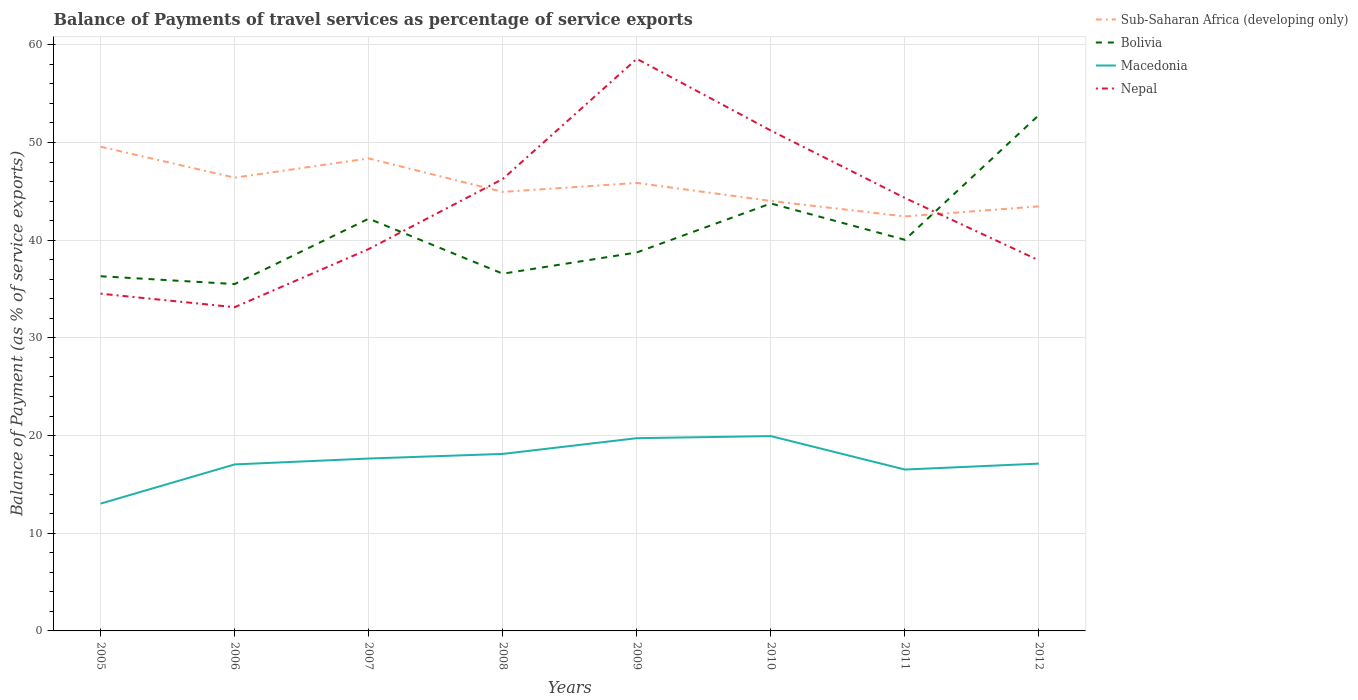How many different coloured lines are there?
Ensure brevity in your answer.  4. Does the line corresponding to Macedonia intersect with the line corresponding to Nepal?
Offer a very short reply. No. Across all years, what is the maximum balance of payments of travel services in Nepal?
Ensure brevity in your answer.  33.14. In which year was the balance of payments of travel services in Sub-Saharan Africa (developing only) maximum?
Keep it short and to the point. 2011. What is the total balance of payments of travel services in Macedonia in the graph?
Make the answer very short. 0.99. What is the difference between the highest and the second highest balance of payments of travel services in Sub-Saharan Africa (developing only)?
Your answer should be compact. 7.14. Is the balance of payments of travel services in Nepal strictly greater than the balance of payments of travel services in Macedonia over the years?
Offer a terse response. No. What is the difference between two consecutive major ticks on the Y-axis?
Make the answer very short. 10. Are the values on the major ticks of Y-axis written in scientific E-notation?
Offer a terse response. No. Does the graph contain any zero values?
Provide a succinct answer. No. How are the legend labels stacked?
Offer a very short reply. Vertical. What is the title of the graph?
Your answer should be compact. Balance of Payments of travel services as percentage of service exports. Does "West Bank and Gaza" appear as one of the legend labels in the graph?
Provide a succinct answer. No. What is the label or title of the Y-axis?
Offer a terse response. Balance of Payment (as % of service exports). What is the Balance of Payment (as % of service exports) in Sub-Saharan Africa (developing only) in 2005?
Ensure brevity in your answer.  49.57. What is the Balance of Payment (as % of service exports) in Bolivia in 2005?
Your answer should be very brief. 36.31. What is the Balance of Payment (as % of service exports) of Macedonia in 2005?
Provide a succinct answer. 13.03. What is the Balance of Payment (as % of service exports) of Nepal in 2005?
Ensure brevity in your answer.  34.52. What is the Balance of Payment (as % of service exports) of Sub-Saharan Africa (developing only) in 2006?
Offer a very short reply. 46.4. What is the Balance of Payment (as % of service exports) of Bolivia in 2006?
Offer a very short reply. 35.51. What is the Balance of Payment (as % of service exports) in Macedonia in 2006?
Ensure brevity in your answer.  17.05. What is the Balance of Payment (as % of service exports) of Nepal in 2006?
Make the answer very short. 33.14. What is the Balance of Payment (as % of service exports) in Sub-Saharan Africa (developing only) in 2007?
Offer a terse response. 48.37. What is the Balance of Payment (as % of service exports) in Bolivia in 2007?
Offer a terse response. 42.2. What is the Balance of Payment (as % of service exports) in Macedonia in 2007?
Give a very brief answer. 17.65. What is the Balance of Payment (as % of service exports) of Nepal in 2007?
Make the answer very short. 39.09. What is the Balance of Payment (as % of service exports) in Sub-Saharan Africa (developing only) in 2008?
Offer a terse response. 44.94. What is the Balance of Payment (as % of service exports) in Bolivia in 2008?
Make the answer very short. 36.57. What is the Balance of Payment (as % of service exports) of Macedonia in 2008?
Ensure brevity in your answer.  18.12. What is the Balance of Payment (as % of service exports) of Nepal in 2008?
Make the answer very short. 46.26. What is the Balance of Payment (as % of service exports) in Sub-Saharan Africa (developing only) in 2009?
Offer a very short reply. 45.86. What is the Balance of Payment (as % of service exports) of Bolivia in 2009?
Provide a short and direct response. 38.75. What is the Balance of Payment (as % of service exports) in Macedonia in 2009?
Your response must be concise. 19.73. What is the Balance of Payment (as % of service exports) in Nepal in 2009?
Provide a succinct answer. 58.57. What is the Balance of Payment (as % of service exports) in Sub-Saharan Africa (developing only) in 2010?
Make the answer very short. 44.02. What is the Balance of Payment (as % of service exports) of Bolivia in 2010?
Offer a terse response. 43.76. What is the Balance of Payment (as % of service exports) of Macedonia in 2010?
Ensure brevity in your answer.  19.94. What is the Balance of Payment (as % of service exports) of Nepal in 2010?
Give a very brief answer. 51.23. What is the Balance of Payment (as % of service exports) of Sub-Saharan Africa (developing only) in 2011?
Ensure brevity in your answer.  42.43. What is the Balance of Payment (as % of service exports) in Bolivia in 2011?
Ensure brevity in your answer.  40.04. What is the Balance of Payment (as % of service exports) of Macedonia in 2011?
Your response must be concise. 16.52. What is the Balance of Payment (as % of service exports) of Nepal in 2011?
Your answer should be compact. 44.33. What is the Balance of Payment (as % of service exports) of Sub-Saharan Africa (developing only) in 2012?
Make the answer very short. 43.46. What is the Balance of Payment (as % of service exports) of Bolivia in 2012?
Your answer should be very brief. 52.82. What is the Balance of Payment (as % of service exports) in Macedonia in 2012?
Your answer should be compact. 17.13. What is the Balance of Payment (as % of service exports) of Nepal in 2012?
Offer a very short reply. 37.93. Across all years, what is the maximum Balance of Payment (as % of service exports) of Sub-Saharan Africa (developing only)?
Your answer should be compact. 49.57. Across all years, what is the maximum Balance of Payment (as % of service exports) of Bolivia?
Make the answer very short. 52.82. Across all years, what is the maximum Balance of Payment (as % of service exports) in Macedonia?
Give a very brief answer. 19.94. Across all years, what is the maximum Balance of Payment (as % of service exports) of Nepal?
Offer a terse response. 58.57. Across all years, what is the minimum Balance of Payment (as % of service exports) in Sub-Saharan Africa (developing only)?
Provide a succinct answer. 42.43. Across all years, what is the minimum Balance of Payment (as % of service exports) of Bolivia?
Your answer should be very brief. 35.51. Across all years, what is the minimum Balance of Payment (as % of service exports) in Macedonia?
Offer a terse response. 13.03. Across all years, what is the minimum Balance of Payment (as % of service exports) in Nepal?
Give a very brief answer. 33.14. What is the total Balance of Payment (as % of service exports) in Sub-Saharan Africa (developing only) in the graph?
Your answer should be very brief. 365.07. What is the total Balance of Payment (as % of service exports) of Bolivia in the graph?
Provide a short and direct response. 325.96. What is the total Balance of Payment (as % of service exports) in Macedonia in the graph?
Give a very brief answer. 139.17. What is the total Balance of Payment (as % of service exports) in Nepal in the graph?
Provide a succinct answer. 345.08. What is the difference between the Balance of Payment (as % of service exports) in Sub-Saharan Africa (developing only) in 2005 and that in 2006?
Your answer should be very brief. 3.17. What is the difference between the Balance of Payment (as % of service exports) in Bolivia in 2005 and that in 2006?
Provide a succinct answer. 0.8. What is the difference between the Balance of Payment (as % of service exports) in Macedonia in 2005 and that in 2006?
Keep it short and to the point. -4.01. What is the difference between the Balance of Payment (as % of service exports) in Nepal in 2005 and that in 2006?
Keep it short and to the point. 1.38. What is the difference between the Balance of Payment (as % of service exports) in Sub-Saharan Africa (developing only) in 2005 and that in 2007?
Offer a very short reply. 1.2. What is the difference between the Balance of Payment (as % of service exports) of Bolivia in 2005 and that in 2007?
Offer a terse response. -5.89. What is the difference between the Balance of Payment (as % of service exports) in Macedonia in 2005 and that in 2007?
Your answer should be very brief. -4.61. What is the difference between the Balance of Payment (as % of service exports) in Nepal in 2005 and that in 2007?
Make the answer very short. -4.57. What is the difference between the Balance of Payment (as % of service exports) of Sub-Saharan Africa (developing only) in 2005 and that in 2008?
Keep it short and to the point. 4.63. What is the difference between the Balance of Payment (as % of service exports) of Bolivia in 2005 and that in 2008?
Give a very brief answer. -0.26. What is the difference between the Balance of Payment (as % of service exports) of Macedonia in 2005 and that in 2008?
Offer a terse response. -5.09. What is the difference between the Balance of Payment (as % of service exports) in Nepal in 2005 and that in 2008?
Offer a terse response. -11.74. What is the difference between the Balance of Payment (as % of service exports) in Sub-Saharan Africa (developing only) in 2005 and that in 2009?
Provide a short and direct response. 3.71. What is the difference between the Balance of Payment (as % of service exports) of Bolivia in 2005 and that in 2009?
Make the answer very short. -2.44. What is the difference between the Balance of Payment (as % of service exports) in Macedonia in 2005 and that in 2009?
Provide a short and direct response. -6.7. What is the difference between the Balance of Payment (as % of service exports) of Nepal in 2005 and that in 2009?
Your answer should be compact. -24.05. What is the difference between the Balance of Payment (as % of service exports) in Sub-Saharan Africa (developing only) in 2005 and that in 2010?
Offer a very short reply. 5.55. What is the difference between the Balance of Payment (as % of service exports) in Bolivia in 2005 and that in 2010?
Keep it short and to the point. -7.45. What is the difference between the Balance of Payment (as % of service exports) in Macedonia in 2005 and that in 2010?
Your answer should be compact. -6.91. What is the difference between the Balance of Payment (as % of service exports) in Nepal in 2005 and that in 2010?
Keep it short and to the point. -16.7. What is the difference between the Balance of Payment (as % of service exports) of Sub-Saharan Africa (developing only) in 2005 and that in 2011?
Provide a succinct answer. 7.14. What is the difference between the Balance of Payment (as % of service exports) of Bolivia in 2005 and that in 2011?
Make the answer very short. -3.73. What is the difference between the Balance of Payment (as % of service exports) in Macedonia in 2005 and that in 2011?
Ensure brevity in your answer.  -3.49. What is the difference between the Balance of Payment (as % of service exports) of Nepal in 2005 and that in 2011?
Your answer should be very brief. -9.8. What is the difference between the Balance of Payment (as % of service exports) in Sub-Saharan Africa (developing only) in 2005 and that in 2012?
Offer a terse response. 6.11. What is the difference between the Balance of Payment (as % of service exports) in Bolivia in 2005 and that in 2012?
Your answer should be compact. -16.51. What is the difference between the Balance of Payment (as % of service exports) of Macedonia in 2005 and that in 2012?
Keep it short and to the point. -4.09. What is the difference between the Balance of Payment (as % of service exports) of Nepal in 2005 and that in 2012?
Ensure brevity in your answer.  -3.41. What is the difference between the Balance of Payment (as % of service exports) of Sub-Saharan Africa (developing only) in 2006 and that in 2007?
Provide a short and direct response. -1.97. What is the difference between the Balance of Payment (as % of service exports) in Bolivia in 2006 and that in 2007?
Make the answer very short. -6.69. What is the difference between the Balance of Payment (as % of service exports) of Macedonia in 2006 and that in 2007?
Give a very brief answer. -0.6. What is the difference between the Balance of Payment (as % of service exports) of Nepal in 2006 and that in 2007?
Ensure brevity in your answer.  -5.95. What is the difference between the Balance of Payment (as % of service exports) in Sub-Saharan Africa (developing only) in 2006 and that in 2008?
Keep it short and to the point. 1.46. What is the difference between the Balance of Payment (as % of service exports) of Bolivia in 2006 and that in 2008?
Provide a short and direct response. -1.06. What is the difference between the Balance of Payment (as % of service exports) in Macedonia in 2006 and that in 2008?
Keep it short and to the point. -1.08. What is the difference between the Balance of Payment (as % of service exports) of Nepal in 2006 and that in 2008?
Provide a short and direct response. -13.12. What is the difference between the Balance of Payment (as % of service exports) of Sub-Saharan Africa (developing only) in 2006 and that in 2009?
Provide a short and direct response. 0.54. What is the difference between the Balance of Payment (as % of service exports) of Bolivia in 2006 and that in 2009?
Offer a very short reply. -3.24. What is the difference between the Balance of Payment (as % of service exports) in Macedonia in 2006 and that in 2009?
Your answer should be very brief. -2.69. What is the difference between the Balance of Payment (as % of service exports) of Nepal in 2006 and that in 2009?
Keep it short and to the point. -25.43. What is the difference between the Balance of Payment (as % of service exports) in Sub-Saharan Africa (developing only) in 2006 and that in 2010?
Provide a succinct answer. 2.38. What is the difference between the Balance of Payment (as % of service exports) in Bolivia in 2006 and that in 2010?
Provide a short and direct response. -8.25. What is the difference between the Balance of Payment (as % of service exports) in Macedonia in 2006 and that in 2010?
Your response must be concise. -2.9. What is the difference between the Balance of Payment (as % of service exports) in Nepal in 2006 and that in 2010?
Keep it short and to the point. -18.08. What is the difference between the Balance of Payment (as % of service exports) in Sub-Saharan Africa (developing only) in 2006 and that in 2011?
Offer a terse response. 3.97. What is the difference between the Balance of Payment (as % of service exports) in Bolivia in 2006 and that in 2011?
Your answer should be very brief. -4.53. What is the difference between the Balance of Payment (as % of service exports) of Macedonia in 2006 and that in 2011?
Your response must be concise. 0.52. What is the difference between the Balance of Payment (as % of service exports) of Nepal in 2006 and that in 2011?
Your answer should be compact. -11.18. What is the difference between the Balance of Payment (as % of service exports) of Sub-Saharan Africa (developing only) in 2006 and that in 2012?
Your answer should be compact. 2.94. What is the difference between the Balance of Payment (as % of service exports) in Bolivia in 2006 and that in 2012?
Offer a terse response. -17.31. What is the difference between the Balance of Payment (as % of service exports) of Macedonia in 2006 and that in 2012?
Ensure brevity in your answer.  -0.08. What is the difference between the Balance of Payment (as % of service exports) of Nepal in 2006 and that in 2012?
Give a very brief answer. -4.79. What is the difference between the Balance of Payment (as % of service exports) of Sub-Saharan Africa (developing only) in 2007 and that in 2008?
Offer a very short reply. 3.43. What is the difference between the Balance of Payment (as % of service exports) of Bolivia in 2007 and that in 2008?
Make the answer very short. 5.63. What is the difference between the Balance of Payment (as % of service exports) of Macedonia in 2007 and that in 2008?
Offer a terse response. -0.47. What is the difference between the Balance of Payment (as % of service exports) in Nepal in 2007 and that in 2008?
Ensure brevity in your answer.  -7.17. What is the difference between the Balance of Payment (as % of service exports) in Sub-Saharan Africa (developing only) in 2007 and that in 2009?
Provide a short and direct response. 2.51. What is the difference between the Balance of Payment (as % of service exports) of Bolivia in 2007 and that in 2009?
Keep it short and to the point. 3.46. What is the difference between the Balance of Payment (as % of service exports) in Macedonia in 2007 and that in 2009?
Provide a succinct answer. -2.08. What is the difference between the Balance of Payment (as % of service exports) of Nepal in 2007 and that in 2009?
Your answer should be compact. -19.48. What is the difference between the Balance of Payment (as % of service exports) in Sub-Saharan Africa (developing only) in 2007 and that in 2010?
Ensure brevity in your answer.  4.35. What is the difference between the Balance of Payment (as % of service exports) in Bolivia in 2007 and that in 2010?
Ensure brevity in your answer.  -1.56. What is the difference between the Balance of Payment (as % of service exports) of Macedonia in 2007 and that in 2010?
Make the answer very short. -2.3. What is the difference between the Balance of Payment (as % of service exports) in Nepal in 2007 and that in 2010?
Keep it short and to the point. -12.13. What is the difference between the Balance of Payment (as % of service exports) of Sub-Saharan Africa (developing only) in 2007 and that in 2011?
Your answer should be very brief. 5.94. What is the difference between the Balance of Payment (as % of service exports) in Bolivia in 2007 and that in 2011?
Your answer should be very brief. 2.16. What is the difference between the Balance of Payment (as % of service exports) in Macedonia in 2007 and that in 2011?
Give a very brief answer. 1.13. What is the difference between the Balance of Payment (as % of service exports) in Nepal in 2007 and that in 2011?
Your answer should be very brief. -5.23. What is the difference between the Balance of Payment (as % of service exports) in Sub-Saharan Africa (developing only) in 2007 and that in 2012?
Your response must be concise. 4.91. What is the difference between the Balance of Payment (as % of service exports) of Bolivia in 2007 and that in 2012?
Give a very brief answer. -10.61. What is the difference between the Balance of Payment (as % of service exports) in Macedonia in 2007 and that in 2012?
Provide a short and direct response. 0.52. What is the difference between the Balance of Payment (as % of service exports) in Nepal in 2007 and that in 2012?
Provide a short and direct response. 1.16. What is the difference between the Balance of Payment (as % of service exports) of Sub-Saharan Africa (developing only) in 2008 and that in 2009?
Offer a very short reply. -0.92. What is the difference between the Balance of Payment (as % of service exports) in Bolivia in 2008 and that in 2009?
Keep it short and to the point. -2.17. What is the difference between the Balance of Payment (as % of service exports) in Macedonia in 2008 and that in 2009?
Offer a terse response. -1.61. What is the difference between the Balance of Payment (as % of service exports) in Nepal in 2008 and that in 2009?
Provide a succinct answer. -12.31. What is the difference between the Balance of Payment (as % of service exports) in Sub-Saharan Africa (developing only) in 2008 and that in 2010?
Your response must be concise. 0.92. What is the difference between the Balance of Payment (as % of service exports) in Bolivia in 2008 and that in 2010?
Provide a short and direct response. -7.19. What is the difference between the Balance of Payment (as % of service exports) in Macedonia in 2008 and that in 2010?
Offer a very short reply. -1.82. What is the difference between the Balance of Payment (as % of service exports) of Nepal in 2008 and that in 2010?
Keep it short and to the point. -4.96. What is the difference between the Balance of Payment (as % of service exports) of Sub-Saharan Africa (developing only) in 2008 and that in 2011?
Offer a terse response. 2.51. What is the difference between the Balance of Payment (as % of service exports) in Bolivia in 2008 and that in 2011?
Offer a terse response. -3.47. What is the difference between the Balance of Payment (as % of service exports) of Macedonia in 2008 and that in 2011?
Give a very brief answer. 1.6. What is the difference between the Balance of Payment (as % of service exports) in Nepal in 2008 and that in 2011?
Your answer should be compact. 1.94. What is the difference between the Balance of Payment (as % of service exports) in Sub-Saharan Africa (developing only) in 2008 and that in 2012?
Ensure brevity in your answer.  1.48. What is the difference between the Balance of Payment (as % of service exports) in Bolivia in 2008 and that in 2012?
Offer a terse response. -16.24. What is the difference between the Balance of Payment (as % of service exports) in Macedonia in 2008 and that in 2012?
Provide a short and direct response. 0.99. What is the difference between the Balance of Payment (as % of service exports) of Nepal in 2008 and that in 2012?
Keep it short and to the point. 8.33. What is the difference between the Balance of Payment (as % of service exports) in Sub-Saharan Africa (developing only) in 2009 and that in 2010?
Your answer should be very brief. 1.84. What is the difference between the Balance of Payment (as % of service exports) of Bolivia in 2009 and that in 2010?
Provide a succinct answer. -5.02. What is the difference between the Balance of Payment (as % of service exports) in Macedonia in 2009 and that in 2010?
Keep it short and to the point. -0.21. What is the difference between the Balance of Payment (as % of service exports) in Nepal in 2009 and that in 2010?
Offer a very short reply. 7.34. What is the difference between the Balance of Payment (as % of service exports) of Sub-Saharan Africa (developing only) in 2009 and that in 2011?
Offer a terse response. 3.43. What is the difference between the Balance of Payment (as % of service exports) of Bolivia in 2009 and that in 2011?
Give a very brief answer. -1.3. What is the difference between the Balance of Payment (as % of service exports) of Macedonia in 2009 and that in 2011?
Your response must be concise. 3.21. What is the difference between the Balance of Payment (as % of service exports) of Nepal in 2009 and that in 2011?
Provide a short and direct response. 14.24. What is the difference between the Balance of Payment (as % of service exports) of Sub-Saharan Africa (developing only) in 2009 and that in 2012?
Provide a short and direct response. 2.4. What is the difference between the Balance of Payment (as % of service exports) of Bolivia in 2009 and that in 2012?
Provide a succinct answer. -14.07. What is the difference between the Balance of Payment (as % of service exports) in Macedonia in 2009 and that in 2012?
Keep it short and to the point. 2.6. What is the difference between the Balance of Payment (as % of service exports) in Nepal in 2009 and that in 2012?
Offer a terse response. 20.64. What is the difference between the Balance of Payment (as % of service exports) of Sub-Saharan Africa (developing only) in 2010 and that in 2011?
Keep it short and to the point. 1.59. What is the difference between the Balance of Payment (as % of service exports) in Bolivia in 2010 and that in 2011?
Offer a very short reply. 3.72. What is the difference between the Balance of Payment (as % of service exports) in Macedonia in 2010 and that in 2011?
Your response must be concise. 3.42. What is the difference between the Balance of Payment (as % of service exports) in Nepal in 2010 and that in 2011?
Offer a very short reply. 6.9. What is the difference between the Balance of Payment (as % of service exports) of Sub-Saharan Africa (developing only) in 2010 and that in 2012?
Give a very brief answer. 0.56. What is the difference between the Balance of Payment (as % of service exports) of Bolivia in 2010 and that in 2012?
Ensure brevity in your answer.  -9.06. What is the difference between the Balance of Payment (as % of service exports) in Macedonia in 2010 and that in 2012?
Offer a terse response. 2.82. What is the difference between the Balance of Payment (as % of service exports) in Nepal in 2010 and that in 2012?
Your response must be concise. 13.29. What is the difference between the Balance of Payment (as % of service exports) of Sub-Saharan Africa (developing only) in 2011 and that in 2012?
Your response must be concise. -1.03. What is the difference between the Balance of Payment (as % of service exports) of Bolivia in 2011 and that in 2012?
Provide a short and direct response. -12.78. What is the difference between the Balance of Payment (as % of service exports) of Macedonia in 2011 and that in 2012?
Ensure brevity in your answer.  -0.61. What is the difference between the Balance of Payment (as % of service exports) of Nepal in 2011 and that in 2012?
Your response must be concise. 6.39. What is the difference between the Balance of Payment (as % of service exports) of Sub-Saharan Africa (developing only) in 2005 and the Balance of Payment (as % of service exports) of Bolivia in 2006?
Your answer should be very brief. 14.06. What is the difference between the Balance of Payment (as % of service exports) in Sub-Saharan Africa (developing only) in 2005 and the Balance of Payment (as % of service exports) in Macedonia in 2006?
Your answer should be very brief. 32.53. What is the difference between the Balance of Payment (as % of service exports) of Sub-Saharan Africa (developing only) in 2005 and the Balance of Payment (as % of service exports) of Nepal in 2006?
Ensure brevity in your answer.  16.43. What is the difference between the Balance of Payment (as % of service exports) of Bolivia in 2005 and the Balance of Payment (as % of service exports) of Macedonia in 2006?
Provide a short and direct response. 19.26. What is the difference between the Balance of Payment (as % of service exports) of Bolivia in 2005 and the Balance of Payment (as % of service exports) of Nepal in 2006?
Your answer should be compact. 3.17. What is the difference between the Balance of Payment (as % of service exports) in Macedonia in 2005 and the Balance of Payment (as % of service exports) in Nepal in 2006?
Offer a very short reply. -20.11. What is the difference between the Balance of Payment (as % of service exports) in Sub-Saharan Africa (developing only) in 2005 and the Balance of Payment (as % of service exports) in Bolivia in 2007?
Give a very brief answer. 7.37. What is the difference between the Balance of Payment (as % of service exports) of Sub-Saharan Africa (developing only) in 2005 and the Balance of Payment (as % of service exports) of Macedonia in 2007?
Make the answer very short. 31.92. What is the difference between the Balance of Payment (as % of service exports) of Sub-Saharan Africa (developing only) in 2005 and the Balance of Payment (as % of service exports) of Nepal in 2007?
Your answer should be compact. 10.48. What is the difference between the Balance of Payment (as % of service exports) in Bolivia in 2005 and the Balance of Payment (as % of service exports) in Macedonia in 2007?
Your answer should be very brief. 18.66. What is the difference between the Balance of Payment (as % of service exports) in Bolivia in 2005 and the Balance of Payment (as % of service exports) in Nepal in 2007?
Provide a short and direct response. -2.78. What is the difference between the Balance of Payment (as % of service exports) of Macedonia in 2005 and the Balance of Payment (as % of service exports) of Nepal in 2007?
Make the answer very short. -26.06. What is the difference between the Balance of Payment (as % of service exports) of Sub-Saharan Africa (developing only) in 2005 and the Balance of Payment (as % of service exports) of Bolivia in 2008?
Ensure brevity in your answer.  13. What is the difference between the Balance of Payment (as % of service exports) of Sub-Saharan Africa (developing only) in 2005 and the Balance of Payment (as % of service exports) of Macedonia in 2008?
Your answer should be very brief. 31.45. What is the difference between the Balance of Payment (as % of service exports) of Sub-Saharan Africa (developing only) in 2005 and the Balance of Payment (as % of service exports) of Nepal in 2008?
Make the answer very short. 3.31. What is the difference between the Balance of Payment (as % of service exports) of Bolivia in 2005 and the Balance of Payment (as % of service exports) of Macedonia in 2008?
Offer a terse response. 18.19. What is the difference between the Balance of Payment (as % of service exports) in Bolivia in 2005 and the Balance of Payment (as % of service exports) in Nepal in 2008?
Give a very brief answer. -9.95. What is the difference between the Balance of Payment (as % of service exports) in Macedonia in 2005 and the Balance of Payment (as % of service exports) in Nepal in 2008?
Your answer should be very brief. -33.23. What is the difference between the Balance of Payment (as % of service exports) in Sub-Saharan Africa (developing only) in 2005 and the Balance of Payment (as % of service exports) in Bolivia in 2009?
Provide a succinct answer. 10.83. What is the difference between the Balance of Payment (as % of service exports) of Sub-Saharan Africa (developing only) in 2005 and the Balance of Payment (as % of service exports) of Macedonia in 2009?
Provide a short and direct response. 29.84. What is the difference between the Balance of Payment (as % of service exports) of Sub-Saharan Africa (developing only) in 2005 and the Balance of Payment (as % of service exports) of Nepal in 2009?
Offer a very short reply. -9. What is the difference between the Balance of Payment (as % of service exports) of Bolivia in 2005 and the Balance of Payment (as % of service exports) of Macedonia in 2009?
Your response must be concise. 16.58. What is the difference between the Balance of Payment (as % of service exports) of Bolivia in 2005 and the Balance of Payment (as % of service exports) of Nepal in 2009?
Provide a short and direct response. -22.26. What is the difference between the Balance of Payment (as % of service exports) in Macedonia in 2005 and the Balance of Payment (as % of service exports) in Nepal in 2009?
Keep it short and to the point. -45.54. What is the difference between the Balance of Payment (as % of service exports) in Sub-Saharan Africa (developing only) in 2005 and the Balance of Payment (as % of service exports) in Bolivia in 2010?
Your answer should be compact. 5.81. What is the difference between the Balance of Payment (as % of service exports) in Sub-Saharan Africa (developing only) in 2005 and the Balance of Payment (as % of service exports) in Macedonia in 2010?
Your answer should be very brief. 29.63. What is the difference between the Balance of Payment (as % of service exports) in Sub-Saharan Africa (developing only) in 2005 and the Balance of Payment (as % of service exports) in Nepal in 2010?
Make the answer very short. -1.65. What is the difference between the Balance of Payment (as % of service exports) in Bolivia in 2005 and the Balance of Payment (as % of service exports) in Macedonia in 2010?
Provide a short and direct response. 16.37. What is the difference between the Balance of Payment (as % of service exports) of Bolivia in 2005 and the Balance of Payment (as % of service exports) of Nepal in 2010?
Provide a succinct answer. -14.92. What is the difference between the Balance of Payment (as % of service exports) of Macedonia in 2005 and the Balance of Payment (as % of service exports) of Nepal in 2010?
Offer a very short reply. -38.19. What is the difference between the Balance of Payment (as % of service exports) of Sub-Saharan Africa (developing only) in 2005 and the Balance of Payment (as % of service exports) of Bolivia in 2011?
Your response must be concise. 9.53. What is the difference between the Balance of Payment (as % of service exports) in Sub-Saharan Africa (developing only) in 2005 and the Balance of Payment (as % of service exports) in Macedonia in 2011?
Offer a very short reply. 33.05. What is the difference between the Balance of Payment (as % of service exports) in Sub-Saharan Africa (developing only) in 2005 and the Balance of Payment (as % of service exports) in Nepal in 2011?
Provide a succinct answer. 5.25. What is the difference between the Balance of Payment (as % of service exports) in Bolivia in 2005 and the Balance of Payment (as % of service exports) in Macedonia in 2011?
Ensure brevity in your answer.  19.79. What is the difference between the Balance of Payment (as % of service exports) in Bolivia in 2005 and the Balance of Payment (as % of service exports) in Nepal in 2011?
Give a very brief answer. -8.01. What is the difference between the Balance of Payment (as % of service exports) of Macedonia in 2005 and the Balance of Payment (as % of service exports) of Nepal in 2011?
Keep it short and to the point. -31.29. What is the difference between the Balance of Payment (as % of service exports) in Sub-Saharan Africa (developing only) in 2005 and the Balance of Payment (as % of service exports) in Bolivia in 2012?
Offer a terse response. -3.25. What is the difference between the Balance of Payment (as % of service exports) of Sub-Saharan Africa (developing only) in 2005 and the Balance of Payment (as % of service exports) of Macedonia in 2012?
Provide a succinct answer. 32.44. What is the difference between the Balance of Payment (as % of service exports) in Sub-Saharan Africa (developing only) in 2005 and the Balance of Payment (as % of service exports) in Nepal in 2012?
Make the answer very short. 11.64. What is the difference between the Balance of Payment (as % of service exports) in Bolivia in 2005 and the Balance of Payment (as % of service exports) in Macedonia in 2012?
Provide a succinct answer. 19.18. What is the difference between the Balance of Payment (as % of service exports) in Bolivia in 2005 and the Balance of Payment (as % of service exports) in Nepal in 2012?
Ensure brevity in your answer.  -1.62. What is the difference between the Balance of Payment (as % of service exports) of Macedonia in 2005 and the Balance of Payment (as % of service exports) of Nepal in 2012?
Offer a terse response. -24.9. What is the difference between the Balance of Payment (as % of service exports) of Sub-Saharan Africa (developing only) in 2006 and the Balance of Payment (as % of service exports) of Bolivia in 2007?
Make the answer very short. 4.2. What is the difference between the Balance of Payment (as % of service exports) of Sub-Saharan Africa (developing only) in 2006 and the Balance of Payment (as % of service exports) of Macedonia in 2007?
Your response must be concise. 28.75. What is the difference between the Balance of Payment (as % of service exports) of Sub-Saharan Africa (developing only) in 2006 and the Balance of Payment (as % of service exports) of Nepal in 2007?
Give a very brief answer. 7.31. What is the difference between the Balance of Payment (as % of service exports) of Bolivia in 2006 and the Balance of Payment (as % of service exports) of Macedonia in 2007?
Provide a succinct answer. 17.86. What is the difference between the Balance of Payment (as % of service exports) in Bolivia in 2006 and the Balance of Payment (as % of service exports) in Nepal in 2007?
Your answer should be compact. -3.58. What is the difference between the Balance of Payment (as % of service exports) in Macedonia in 2006 and the Balance of Payment (as % of service exports) in Nepal in 2007?
Make the answer very short. -22.05. What is the difference between the Balance of Payment (as % of service exports) in Sub-Saharan Africa (developing only) in 2006 and the Balance of Payment (as % of service exports) in Bolivia in 2008?
Offer a very short reply. 9.83. What is the difference between the Balance of Payment (as % of service exports) of Sub-Saharan Africa (developing only) in 2006 and the Balance of Payment (as % of service exports) of Macedonia in 2008?
Offer a very short reply. 28.28. What is the difference between the Balance of Payment (as % of service exports) of Sub-Saharan Africa (developing only) in 2006 and the Balance of Payment (as % of service exports) of Nepal in 2008?
Your answer should be compact. 0.14. What is the difference between the Balance of Payment (as % of service exports) of Bolivia in 2006 and the Balance of Payment (as % of service exports) of Macedonia in 2008?
Give a very brief answer. 17.39. What is the difference between the Balance of Payment (as % of service exports) in Bolivia in 2006 and the Balance of Payment (as % of service exports) in Nepal in 2008?
Give a very brief answer. -10.75. What is the difference between the Balance of Payment (as % of service exports) of Macedonia in 2006 and the Balance of Payment (as % of service exports) of Nepal in 2008?
Your response must be concise. -29.22. What is the difference between the Balance of Payment (as % of service exports) in Sub-Saharan Africa (developing only) in 2006 and the Balance of Payment (as % of service exports) in Bolivia in 2009?
Make the answer very short. 7.66. What is the difference between the Balance of Payment (as % of service exports) in Sub-Saharan Africa (developing only) in 2006 and the Balance of Payment (as % of service exports) in Macedonia in 2009?
Offer a terse response. 26.67. What is the difference between the Balance of Payment (as % of service exports) of Sub-Saharan Africa (developing only) in 2006 and the Balance of Payment (as % of service exports) of Nepal in 2009?
Offer a terse response. -12.17. What is the difference between the Balance of Payment (as % of service exports) in Bolivia in 2006 and the Balance of Payment (as % of service exports) in Macedonia in 2009?
Provide a succinct answer. 15.78. What is the difference between the Balance of Payment (as % of service exports) of Bolivia in 2006 and the Balance of Payment (as % of service exports) of Nepal in 2009?
Keep it short and to the point. -23.06. What is the difference between the Balance of Payment (as % of service exports) of Macedonia in 2006 and the Balance of Payment (as % of service exports) of Nepal in 2009?
Provide a short and direct response. -41.52. What is the difference between the Balance of Payment (as % of service exports) of Sub-Saharan Africa (developing only) in 2006 and the Balance of Payment (as % of service exports) of Bolivia in 2010?
Ensure brevity in your answer.  2.64. What is the difference between the Balance of Payment (as % of service exports) in Sub-Saharan Africa (developing only) in 2006 and the Balance of Payment (as % of service exports) in Macedonia in 2010?
Keep it short and to the point. 26.46. What is the difference between the Balance of Payment (as % of service exports) in Sub-Saharan Africa (developing only) in 2006 and the Balance of Payment (as % of service exports) in Nepal in 2010?
Your answer should be very brief. -4.82. What is the difference between the Balance of Payment (as % of service exports) of Bolivia in 2006 and the Balance of Payment (as % of service exports) of Macedonia in 2010?
Make the answer very short. 15.57. What is the difference between the Balance of Payment (as % of service exports) of Bolivia in 2006 and the Balance of Payment (as % of service exports) of Nepal in 2010?
Give a very brief answer. -15.72. What is the difference between the Balance of Payment (as % of service exports) in Macedonia in 2006 and the Balance of Payment (as % of service exports) in Nepal in 2010?
Provide a short and direct response. -34.18. What is the difference between the Balance of Payment (as % of service exports) in Sub-Saharan Africa (developing only) in 2006 and the Balance of Payment (as % of service exports) in Bolivia in 2011?
Keep it short and to the point. 6.36. What is the difference between the Balance of Payment (as % of service exports) in Sub-Saharan Africa (developing only) in 2006 and the Balance of Payment (as % of service exports) in Macedonia in 2011?
Offer a terse response. 29.88. What is the difference between the Balance of Payment (as % of service exports) of Sub-Saharan Africa (developing only) in 2006 and the Balance of Payment (as % of service exports) of Nepal in 2011?
Your answer should be very brief. 2.08. What is the difference between the Balance of Payment (as % of service exports) in Bolivia in 2006 and the Balance of Payment (as % of service exports) in Macedonia in 2011?
Your answer should be very brief. 18.99. What is the difference between the Balance of Payment (as % of service exports) in Bolivia in 2006 and the Balance of Payment (as % of service exports) in Nepal in 2011?
Offer a very short reply. -8.81. What is the difference between the Balance of Payment (as % of service exports) in Macedonia in 2006 and the Balance of Payment (as % of service exports) in Nepal in 2011?
Provide a succinct answer. -27.28. What is the difference between the Balance of Payment (as % of service exports) in Sub-Saharan Africa (developing only) in 2006 and the Balance of Payment (as % of service exports) in Bolivia in 2012?
Your answer should be very brief. -6.41. What is the difference between the Balance of Payment (as % of service exports) in Sub-Saharan Africa (developing only) in 2006 and the Balance of Payment (as % of service exports) in Macedonia in 2012?
Provide a short and direct response. 29.27. What is the difference between the Balance of Payment (as % of service exports) of Sub-Saharan Africa (developing only) in 2006 and the Balance of Payment (as % of service exports) of Nepal in 2012?
Offer a very short reply. 8.47. What is the difference between the Balance of Payment (as % of service exports) of Bolivia in 2006 and the Balance of Payment (as % of service exports) of Macedonia in 2012?
Give a very brief answer. 18.38. What is the difference between the Balance of Payment (as % of service exports) in Bolivia in 2006 and the Balance of Payment (as % of service exports) in Nepal in 2012?
Your answer should be very brief. -2.42. What is the difference between the Balance of Payment (as % of service exports) of Macedonia in 2006 and the Balance of Payment (as % of service exports) of Nepal in 2012?
Make the answer very short. -20.89. What is the difference between the Balance of Payment (as % of service exports) in Sub-Saharan Africa (developing only) in 2007 and the Balance of Payment (as % of service exports) in Bolivia in 2008?
Offer a very short reply. 11.8. What is the difference between the Balance of Payment (as % of service exports) in Sub-Saharan Africa (developing only) in 2007 and the Balance of Payment (as % of service exports) in Macedonia in 2008?
Make the answer very short. 30.25. What is the difference between the Balance of Payment (as % of service exports) of Sub-Saharan Africa (developing only) in 2007 and the Balance of Payment (as % of service exports) of Nepal in 2008?
Your response must be concise. 2.11. What is the difference between the Balance of Payment (as % of service exports) in Bolivia in 2007 and the Balance of Payment (as % of service exports) in Macedonia in 2008?
Ensure brevity in your answer.  24.08. What is the difference between the Balance of Payment (as % of service exports) of Bolivia in 2007 and the Balance of Payment (as % of service exports) of Nepal in 2008?
Make the answer very short. -4.06. What is the difference between the Balance of Payment (as % of service exports) of Macedonia in 2007 and the Balance of Payment (as % of service exports) of Nepal in 2008?
Make the answer very short. -28.62. What is the difference between the Balance of Payment (as % of service exports) in Sub-Saharan Africa (developing only) in 2007 and the Balance of Payment (as % of service exports) in Bolivia in 2009?
Provide a succinct answer. 9.63. What is the difference between the Balance of Payment (as % of service exports) in Sub-Saharan Africa (developing only) in 2007 and the Balance of Payment (as % of service exports) in Macedonia in 2009?
Keep it short and to the point. 28.64. What is the difference between the Balance of Payment (as % of service exports) of Sub-Saharan Africa (developing only) in 2007 and the Balance of Payment (as % of service exports) of Nepal in 2009?
Provide a short and direct response. -10.2. What is the difference between the Balance of Payment (as % of service exports) in Bolivia in 2007 and the Balance of Payment (as % of service exports) in Macedonia in 2009?
Your answer should be very brief. 22.47. What is the difference between the Balance of Payment (as % of service exports) of Bolivia in 2007 and the Balance of Payment (as % of service exports) of Nepal in 2009?
Give a very brief answer. -16.37. What is the difference between the Balance of Payment (as % of service exports) in Macedonia in 2007 and the Balance of Payment (as % of service exports) in Nepal in 2009?
Offer a terse response. -40.92. What is the difference between the Balance of Payment (as % of service exports) in Sub-Saharan Africa (developing only) in 2007 and the Balance of Payment (as % of service exports) in Bolivia in 2010?
Provide a short and direct response. 4.61. What is the difference between the Balance of Payment (as % of service exports) in Sub-Saharan Africa (developing only) in 2007 and the Balance of Payment (as % of service exports) in Macedonia in 2010?
Your answer should be very brief. 28.43. What is the difference between the Balance of Payment (as % of service exports) of Sub-Saharan Africa (developing only) in 2007 and the Balance of Payment (as % of service exports) of Nepal in 2010?
Keep it short and to the point. -2.86. What is the difference between the Balance of Payment (as % of service exports) of Bolivia in 2007 and the Balance of Payment (as % of service exports) of Macedonia in 2010?
Your answer should be compact. 22.26. What is the difference between the Balance of Payment (as % of service exports) of Bolivia in 2007 and the Balance of Payment (as % of service exports) of Nepal in 2010?
Give a very brief answer. -9.02. What is the difference between the Balance of Payment (as % of service exports) of Macedonia in 2007 and the Balance of Payment (as % of service exports) of Nepal in 2010?
Ensure brevity in your answer.  -33.58. What is the difference between the Balance of Payment (as % of service exports) of Sub-Saharan Africa (developing only) in 2007 and the Balance of Payment (as % of service exports) of Bolivia in 2011?
Provide a succinct answer. 8.33. What is the difference between the Balance of Payment (as % of service exports) of Sub-Saharan Africa (developing only) in 2007 and the Balance of Payment (as % of service exports) of Macedonia in 2011?
Provide a succinct answer. 31.85. What is the difference between the Balance of Payment (as % of service exports) in Sub-Saharan Africa (developing only) in 2007 and the Balance of Payment (as % of service exports) in Nepal in 2011?
Your response must be concise. 4.05. What is the difference between the Balance of Payment (as % of service exports) in Bolivia in 2007 and the Balance of Payment (as % of service exports) in Macedonia in 2011?
Provide a succinct answer. 25.68. What is the difference between the Balance of Payment (as % of service exports) of Bolivia in 2007 and the Balance of Payment (as % of service exports) of Nepal in 2011?
Your response must be concise. -2.12. What is the difference between the Balance of Payment (as % of service exports) of Macedonia in 2007 and the Balance of Payment (as % of service exports) of Nepal in 2011?
Offer a terse response. -26.68. What is the difference between the Balance of Payment (as % of service exports) in Sub-Saharan Africa (developing only) in 2007 and the Balance of Payment (as % of service exports) in Bolivia in 2012?
Offer a very short reply. -4.45. What is the difference between the Balance of Payment (as % of service exports) in Sub-Saharan Africa (developing only) in 2007 and the Balance of Payment (as % of service exports) in Macedonia in 2012?
Your response must be concise. 31.24. What is the difference between the Balance of Payment (as % of service exports) of Sub-Saharan Africa (developing only) in 2007 and the Balance of Payment (as % of service exports) of Nepal in 2012?
Offer a very short reply. 10.44. What is the difference between the Balance of Payment (as % of service exports) of Bolivia in 2007 and the Balance of Payment (as % of service exports) of Macedonia in 2012?
Offer a terse response. 25.07. What is the difference between the Balance of Payment (as % of service exports) of Bolivia in 2007 and the Balance of Payment (as % of service exports) of Nepal in 2012?
Provide a short and direct response. 4.27. What is the difference between the Balance of Payment (as % of service exports) of Macedonia in 2007 and the Balance of Payment (as % of service exports) of Nepal in 2012?
Give a very brief answer. -20.29. What is the difference between the Balance of Payment (as % of service exports) of Sub-Saharan Africa (developing only) in 2008 and the Balance of Payment (as % of service exports) of Bolivia in 2009?
Give a very brief answer. 6.2. What is the difference between the Balance of Payment (as % of service exports) of Sub-Saharan Africa (developing only) in 2008 and the Balance of Payment (as % of service exports) of Macedonia in 2009?
Keep it short and to the point. 25.21. What is the difference between the Balance of Payment (as % of service exports) of Sub-Saharan Africa (developing only) in 2008 and the Balance of Payment (as % of service exports) of Nepal in 2009?
Keep it short and to the point. -13.63. What is the difference between the Balance of Payment (as % of service exports) of Bolivia in 2008 and the Balance of Payment (as % of service exports) of Macedonia in 2009?
Provide a succinct answer. 16.84. What is the difference between the Balance of Payment (as % of service exports) of Bolivia in 2008 and the Balance of Payment (as % of service exports) of Nepal in 2009?
Offer a terse response. -22. What is the difference between the Balance of Payment (as % of service exports) in Macedonia in 2008 and the Balance of Payment (as % of service exports) in Nepal in 2009?
Keep it short and to the point. -40.45. What is the difference between the Balance of Payment (as % of service exports) in Sub-Saharan Africa (developing only) in 2008 and the Balance of Payment (as % of service exports) in Bolivia in 2010?
Offer a very short reply. 1.18. What is the difference between the Balance of Payment (as % of service exports) of Sub-Saharan Africa (developing only) in 2008 and the Balance of Payment (as % of service exports) of Macedonia in 2010?
Provide a short and direct response. 25. What is the difference between the Balance of Payment (as % of service exports) of Sub-Saharan Africa (developing only) in 2008 and the Balance of Payment (as % of service exports) of Nepal in 2010?
Ensure brevity in your answer.  -6.28. What is the difference between the Balance of Payment (as % of service exports) of Bolivia in 2008 and the Balance of Payment (as % of service exports) of Macedonia in 2010?
Give a very brief answer. 16.63. What is the difference between the Balance of Payment (as % of service exports) of Bolivia in 2008 and the Balance of Payment (as % of service exports) of Nepal in 2010?
Keep it short and to the point. -14.65. What is the difference between the Balance of Payment (as % of service exports) in Macedonia in 2008 and the Balance of Payment (as % of service exports) in Nepal in 2010?
Ensure brevity in your answer.  -33.11. What is the difference between the Balance of Payment (as % of service exports) of Sub-Saharan Africa (developing only) in 2008 and the Balance of Payment (as % of service exports) of Bolivia in 2011?
Offer a terse response. 4.9. What is the difference between the Balance of Payment (as % of service exports) of Sub-Saharan Africa (developing only) in 2008 and the Balance of Payment (as % of service exports) of Macedonia in 2011?
Your answer should be very brief. 28.42. What is the difference between the Balance of Payment (as % of service exports) in Sub-Saharan Africa (developing only) in 2008 and the Balance of Payment (as % of service exports) in Nepal in 2011?
Offer a terse response. 0.62. What is the difference between the Balance of Payment (as % of service exports) of Bolivia in 2008 and the Balance of Payment (as % of service exports) of Macedonia in 2011?
Provide a short and direct response. 20.05. What is the difference between the Balance of Payment (as % of service exports) in Bolivia in 2008 and the Balance of Payment (as % of service exports) in Nepal in 2011?
Offer a very short reply. -7.75. What is the difference between the Balance of Payment (as % of service exports) in Macedonia in 2008 and the Balance of Payment (as % of service exports) in Nepal in 2011?
Your answer should be very brief. -26.2. What is the difference between the Balance of Payment (as % of service exports) in Sub-Saharan Africa (developing only) in 2008 and the Balance of Payment (as % of service exports) in Bolivia in 2012?
Ensure brevity in your answer.  -7.87. What is the difference between the Balance of Payment (as % of service exports) in Sub-Saharan Africa (developing only) in 2008 and the Balance of Payment (as % of service exports) in Macedonia in 2012?
Ensure brevity in your answer.  27.82. What is the difference between the Balance of Payment (as % of service exports) of Sub-Saharan Africa (developing only) in 2008 and the Balance of Payment (as % of service exports) of Nepal in 2012?
Offer a terse response. 7.01. What is the difference between the Balance of Payment (as % of service exports) of Bolivia in 2008 and the Balance of Payment (as % of service exports) of Macedonia in 2012?
Offer a terse response. 19.45. What is the difference between the Balance of Payment (as % of service exports) of Bolivia in 2008 and the Balance of Payment (as % of service exports) of Nepal in 2012?
Your answer should be very brief. -1.36. What is the difference between the Balance of Payment (as % of service exports) of Macedonia in 2008 and the Balance of Payment (as % of service exports) of Nepal in 2012?
Give a very brief answer. -19.81. What is the difference between the Balance of Payment (as % of service exports) of Sub-Saharan Africa (developing only) in 2009 and the Balance of Payment (as % of service exports) of Bolivia in 2010?
Offer a very short reply. 2.1. What is the difference between the Balance of Payment (as % of service exports) in Sub-Saharan Africa (developing only) in 2009 and the Balance of Payment (as % of service exports) in Macedonia in 2010?
Make the answer very short. 25.92. What is the difference between the Balance of Payment (as % of service exports) of Sub-Saharan Africa (developing only) in 2009 and the Balance of Payment (as % of service exports) of Nepal in 2010?
Give a very brief answer. -5.36. What is the difference between the Balance of Payment (as % of service exports) of Bolivia in 2009 and the Balance of Payment (as % of service exports) of Macedonia in 2010?
Make the answer very short. 18.8. What is the difference between the Balance of Payment (as % of service exports) in Bolivia in 2009 and the Balance of Payment (as % of service exports) in Nepal in 2010?
Offer a terse response. -12.48. What is the difference between the Balance of Payment (as % of service exports) of Macedonia in 2009 and the Balance of Payment (as % of service exports) of Nepal in 2010?
Keep it short and to the point. -31.5. What is the difference between the Balance of Payment (as % of service exports) of Sub-Saharan Africa (developing only) in 2009 and the Balance of Payment (as % of service exports) of Bolivia in 2011?
Give a very brief answer. 5.82. What is the difference between the Balance of Payment (as % of service exports) of Sub-Saharan Africa (developing only) in 2009 and the Balance of Payment (as % of service exports) of Macedonia in 2011?
Your answer should be very brief. 29.34. What is the difference between the Balance of Payment (as % of service exports) in Sub-Saharan Africa (developing only) in 2009 and the Balance of Payment (as % of service exports) in Nepal in 2011?
Make the answer very short. 1.54. What is the difference between the Balance of Payment (as % of service exports) in Bolivia in 2009 and the Balance of Payment (as % of service exports) in Macedonia in 2011?
Give a very brief answer. 22.23. What is the difference between the Balance of Payment (as % of service exports) in Bolivia in 2009 and the Balance of Payment (as % of service exports) in Nepal in 2011?
Make the answer very short. -5.58. What is the difference between the Balance of Payment (as % of service exports) of Macedonia in 2009 and the Balance of Payment (as % of service exports) of Nepal in 2011?
Make the answer very short. -24.59. What is the difference between the Balance of Payment (as % of service exports) of Sub-Saharan Africa (developing only) in 2009 and the Balance of Payment (as % of service exports) of Bolivia in 2012?
Keep it short and to the point. -6.95. What is the difference between the Balance of Payment (as % of service exports) of Sub-Saharan Africa (developing only) in 2009 and the Balance of Payment (as % of service exports) of Macedonia in 2012?
Make the answer very short. 28.74. What is the difference between the Balance of Payment (as % of service exports) of Sub-Saharan Africa (developing only) in 2009 and the Balance of Payment (as % of service exports) of Nepal in 2012?
Give a very brief answer. 7.93. What is the difference between the Balance of Payment (as % of service exports) in Bolivia in 2009 and the Balance of Payment (as % of service exports) in Macedonia in 2012?
Ensure brevity in your answer.  21.62. What is the difference between the Balance of Payment (as % of service exports) of Bolivia in 2009 and the Balance of Payment (as % of service exports) of Nepal in 2012?
Give a very brief answer. 0.81. What is the difference between the Balance of Payment (as % of service exports) in Macedonia in 2009 and the Balance of Payment (as % of service exports) in Nepal in 2012?
Your answer should be very brief. -18.2. What is the difference between the Balance of Payment (as % of service exports) of Sub-Saharan Africa (developing only) in 2010 and the Balance of Payment (as % of service exports) of Bolivia in 2011?
Provide a short and direct response. 3.98. What is the difference between the Balance of Payment (as % of service exports) of Sub-Saharan Africa (developing only) in 2010 and the Balance of Payment (as % of service exports) of Macedonia in 2011?
Your response must be concise. 27.5. What is the difference between the Balance of Payment (as % of service exports) of Sub-Saharan Africa (developing only) in 2010 and the Balance of Payment (as % of service exports) of Nepal in 2011?
Make the answer very short. -0.31. What is the difference between the Balance of Payment (as % of service exports) in Bolivia in 2010 and the Balance of Payment (as % of service exports) in Macedonia in 2011?
Ensure brevity in your answer.  27.24. What is the difference between the Balance of Payment (as % of service exports) of Bolivia in 2010 and the Balance of Payment (as % of service exports) of Nepal in 2011?
Provide a short and direct response. -0.56. What is the difference between the Balance of Payment (as % of service exports) in Macedonia in 2010 and the Balance of Payment (as % of service exports) in Nepal in 2011?
Make the answer very short. -24.38. What is the difference between the Balance of Payment (as % of service exports) in Sub-Saharan Africa (developing only) in 2010 and the Balance of Payment (as % of service exports) in Bolivia in 2012?
Keep it short and to the point. -8.8. What is the difference between the Balance of Payment (as % of service exports) of Sub-Saharan Africa (developing only) in 2010 and the Balance of Payment (as % of service exports) of Macedonia in 2012?
Provide a succinct answer. 26.89. What is the difference between the Balance of Payment (as % of service exports) of Sub-Saharan Africa (developing only) in 2010 and the Balance of Payment (as % of service exports) of Nepal in 2012?
Provide a short and direct response. 6.09. What is the difference between the Balance of Payment (as % of service exports) of Bolivia in 2010 and the Balance of Payment (as % of service exports) of Macedonia in 2012?
Your answer should be compact. 26.63. What is the difference between the Balance of Payment (as % of service exports) in Bolivia in 2010 and the Balance of Payment (as % of service exports) in Nepal in 2012?
Give a very brief answer. 5.83. What is the difference between the Balance of Payment (as % of service exports) in Macedonia in 2010 and the Balance of Payment (as % of service exports) in Nepal in 2012?
Offer a terse response. -17.99. What is the difference between the Balance of Payment (as % of service exports) in Sub-Saharan Africa (developing only) in 2011 and the Balance of Payment (as % of service exports) in Bolivia in 2012?
Your answer should be compact. -10.38. What is the difference between the Balance of Payment (as % of service exports) of Sub-Saharan Africa (developing only) in 2011 and the Balance of Payment (as % of service exports) of Macedonia in 2012?
Give a very brief answer. 25.31. What is the difference between the Balance of Payment (as % of service exports) in Sub-Saharan Africa (developing only) in 2011 and the Balance of Payment (as % of service exports) in Nepal in 2012?
Provide a short and direct response. 4.5. What is the difference between the Balance of Payment (as % of service exports) in Bolivia in 2011 and the Balance of Payment (as % of service exports) in Macedonia in 2012?
Offer a terse response. 22.91. What is the difference between the Balance of Payment (as % of service exports) in Bolivia in 2011 and the Balance of Payment (as % of service exports) in Nepal in 2012?
Provide a succinct answer. 2.11. What is the difference between the Balance of Payment (as % of service exports) of Macedonia in 2011 and the Balance of Payment (as % of service exports) of Nepal in 2012?
Your response must be concise. -21.41. What is the average Balance of Payment (as % of service exports) in Sub-Saharan Africa (developing only) per year?
Make the answer very short. 45.63. What is the average Balance of Payment (as % of service exports) of Bolivia per year?
Offer a terse response. 40.75. What is the average Balance of Payment (as % of service exports) in Macedonia per year?
Offer a very short reply. 17.4. What is the average Balance of Payment (as % of service exports) of Nepal per year?
Give a very brief answer. 43.13. In the year 2005, what is the difference between the Balance of Payment (as % of service exports) in Sub-Saharan Africa (developing only) and Balance of Payment (as % of service exports) in Bolivia?
Your answer should be very brief. 13.26. In the year 2005, what is the difference between the Balance of Payment (as % of service exports) of Sub-Saharan Africa (developing only) and Balance of Payment (as % of service exports) of Macedonia?
Ensure brevity in your answer.  36.54. In the year 2005, what is the difference between the Balance of Payment (as % of service exports) of Sub-Saharan Africa (developing only) and Balance of Payment (as % of service exports) of Nepal?
Offer a very short reply. 15.05. In the year 2005, what is the difference between the Balance of Payment (as % of service exports) of Bolivia and Balance of Payment (as % of service exports) of Macedonia?
Provide a short and direct response. 23.28. In the year 2005, what is the difference between the Balance of Payment (as % of service exports) of Bolivia and Balance of Payment (as % of service exports) of Nepal?
Offer a very short reply. 1.79. In the year 2005, what is the difference between the Balance of Payment (as % of service exports) in Macedonia and Balance of Payment (as % of service exports) in Nepal?
Your response must be concise. -21.49. In the year 2006, what is the difference between the Balance of Payment (as % of service exports) of Sub-Saharan Africa (developing only) and Balance of Payment (as % of service exports) of Bolivia?
Your response must be concise. 10.89. In the year 2006, what is the difference between the Balance of Payment (as % of service exports) in Sub-Saharan Africa (developing only) and Balance of Payment (as % of service exports) in Macedonia?
Your response must be concise. 29.36. In the year 2006, what is the difference between the Balance of Payment (as % of service exports) of Sub-Saharan Africa (developing only) and Balance of Payment (as % of service exports) of Nepal?
Offer a terse response. 13.26. In the year 2006, what is the difference between the Balance of Payment (as % of service exports) in Bolivia and Balance of Payment (as % of service exports) in Macedonia?
Keep it short and to the point. 18.47. In the year 2006, what is the difference between the Balance of Payment (as % of service exports) of Bolivia and Balance of Payment (as % of service exports) of Nepal?
Ensure brevity in your answer.  2.37. In the year 2006, what is the difference between the Balance of Payment (as % of service exports) in Macedonia and Balance of Payment (as % of service exports) in Nepal?
Offer a terse response. -16.1. In the year 2007, what is the difference between the Balance of Payment (as % of service exports) in Sub-Saharan Africa (developing only) and Balance of Payment (as % of service exports) in Bolivia?
Ensure brevity in your answer.  6.17. In the year 2007, what is the difference between the Balance of Payment (as % of service exports) of Sub-Saharan Africa (developing only) and Balance of Payment (as % of service exports) of Macedonia?
Keep it short and to the point. 30.72. In the year 2007, what is the difference between the Balance of Payment (as % of service exports) in Sub-Saharan Africa (developing only) and Balance of Payment (as % of service exports) in Nepal?
Ensure brevity in your answer.  9.28. In the year 2007, what is the difference between the Balance of Payment (as % of service exports) of Bolivia and Balance of Payment (as % of service exports) of Macedonia?
Your answer should be very brief. 24.55. In the year 2007, what is the difference between the Balance of Payment (as % of service exports) in Bolivia and Balance of Payment (as % of service exports) in Nepal?
Keep it short and to the point. 3.11. In the year 2007, what is the difference between the Balance of Payment (as % of service exports) in Macedonia and Balance of Payment (as % of service exports) in Nepal?
Ensure brevity in your answer.  -21.44. In the year 2008, what is the difference between the Balance of Payment (as % of service exports) in Sub-Saharan Africa (developing only) and Balance of Payment (as % of service exports) in Bolivia?
Keep it short and to the point. 8.37. In the year 2008, what is the difference between the Balance of Payment (as % of service exports) of Sub-Saharan Africa (developing only) and Balance of Payment (as % of service exports) of Macedonia?
Your answer should be compact. 26.82. In the year 2008, what is the difference between the Balance of Payment (as % of service exports) of Sub-Saharan Africa (developing only) and Balance of Payment (as % of service exports) of Nepal?
Provide a short and direct response. -1.32. In the year 2008, what is the difference between the Balance of Payment (as % of service exports) in Bolivia and Balance of Payment (as % of service exports) in Macedonia?
Provide a succinct answer. 18.45. In the year 2008, what is the difference between the Balance of Payment (as % of service exports) of Bolivia and Balance of Payment (as % of service exports) of Nepal?
Keep it short and to the point. -9.69. In the year 2008, what is the difference between the Balance of Payment (as % of service exports) in Macedonia and Balance of Payment (as % of service exports) in Nepal?
Provide a short and direct response. -28.14. In the year 2009, what is the difference between the Balance of Payment (as % of service exports) of Sub-Saharan Africa (developing only) and Balance of Payment (as % of service exports) of Bolivia?
Offer a terse response. 7.12. In the year 2009, what is the difference between the Balance of Payment (as % of service exports) in Sub-Saharan Africa (developing only) and Balance of Payment (as % of service exports) in Macedonia?
Ensure brevity in your answer.  26.13. In the year 2009, what is the difference between the Balance of Payment (as % of service exports) of Sub-Saharan Africa (developing only) and Balance of Payment (as % of service exports) of Nepal?
Offer a very short reply. -12.71. In the year 2009, what is the difference between the Balance of Payment (as % of service exports) of Bolivia and Balance of Payment (as % of service exports) of Macedonia?
Your answer should be compact. 19.01. In the year 2009, what is the difference between the Balance of Payment (as % of service exports) of Bolivia and Balance of Payment (as % of service exports) of Nepal?
Your answer should be compact. -19.82. In the year 2009, what is the difference between the Balance of Payment (as % of service exports) of Macedonia and Balance of Payment (as % of service exports) of Nepal?
Give a very brief answer. -38.84. In the year 2010, what is the difference between the Balance of Payment (as % of service exports) of Sub-Saharan Africa (developing only) and Balance of Payment (as % of service exports) of Bolivia?
Your response must be concise. 0.26. In the year 2010, what is the difference between the Balance of Payment (as % of service exports) of Sub-Saharan Africa (developing only) and Balance of Payment (as % of service exports) of Macedonia?
Your response must be concise. 24.07. In the year 2010, what is the difference between the Balance of Payment (as % of service exports) of Sub-Saharan Africa (developing only) and Balance of Payment (as % of service exports) of Nepal?
Ensure brevity in your answer.  -7.21. In the year 2010, what is the difference between the Balance of Payment (as % of service exports) of Bolivia and Balance of Payment (as % of service exports) of Macedonia?
Your answer should be compact. 23.82. In the year 2010, what is the difference between the Balance of Payment (as % of service exports) in Bolivia and Balance of Payment (as % of service exports) in Nepal?
Your answer should be very brief. -7.47. In the year 2010, what is the difference between the Balance of Payment (as % of service exports) in Macedonia and Balance of Payment (as % of service exports) in Nepal?
Your answer should be very brief. -31.28. In the year 2011, what is the difference between the Balance of Payment (as % of service exports) in Sub-Saharan Africa (developing only) and Balance of Payment (as % of service exports) in Bolivia?
Offer a very short reply. 2.39. In the year 2011, what is the difference between the Balance of Payment (as % of service exports) of Sub-Saharan Africa (developing only) and Balance of Payment (as % of service exports) of Macedonia?
Provide a succinct answer. 25.91. In the year 2011, what is the difference between the Balance of Payment (as % of service exports) in Sub-Saharan Africa (developing only) and Balance of Payment (as % of service exports) in Nepal?
Your response must be concise. -1.89. In the year 2011, what is the difference between the Balance of Payment (as % of service exports) in Bolivia and Balance of Payment (as % of service exports) in Macedonia?
Keep it short and to the point. 23.52. In the year 2011, what is the difference between the Balance of Payment (as % of service exports) of Bolivia and Balance of Payment (as % of service exports) of Nepal?
Your answer should be very brief. -4.28. In the year 2011, what is the difference between the Balance of Payment (as % of service exports) in Macedonia and Balance of Payment (as % of service exports) in Nepal?
Ensure brevity in your answer.  -27.8. In the year 2012, what is the difference between the Balance of Payment (as % of service exports) in Sub-Saharan Africa (developing only) and Balance of Payment (as % of service exports) in Bolivia?
Offer a very short reply. -9.35. In the year 2012, what is the difference between the Balance of Payment (as % of service exports) of Sub-Saharan Africa (developing only) and Balance of Payment (as % of service exports) of Macedonia?
Your response must be concise. 26.34. In the year 2012, what is the difference between the Balance of Payment (as % of service exports) of Sub-Saharan Africa (developing only) and Balance of Payment (as % of service exports) of Nepal?
Your response must be concise. 5.53. In the year 2012, what is the difference between the Balance of Payment (as % of service exports) of Bolivia and Balance of Payment (as % of service exports) of Macedonia?
Your answer should be compact. 35.69. In the year 2012, what is the difference between the Balance of Payment (as % of service exports) in Bolivia and Balance of Payment (as % of service exports) in Nepal?
Offer a very short reply. 14.88. In the year 2012, what is the difference between the Balance of Payment (as % of service exports) in Macedonia and Balance of Payment (as % of service exports) in Nepal?
Give a very brief answer. -20.81. What is the ratio of the Balance of Payment (as % of service exports) in Sub-Saharan Africa (developing only) in 2005 to that in 2006?
Offer a terse response. 1.07. What is the ratio of the Balance of Payment (as % of service exports) of Bolivia in 2005 to that in 2006?
Your response must be concise. 1.02. What is the ratio of the Balance of Payment (as % of service exports) in Macedonia in 2005 to that in 2006?
Make the answer very short. 0.76. What is the ratio of the Balance of Payment (as % of service exports) in Nepal in 2005 to that in 2006?
Provide a succinct answer. 1.04. What is the ratio of the Balance of Payment (as % of service exports) of Sub-Saharan Africa (developing only) in 2005 to that in 2007?
Provide a short and direct response. 1.02. What is the ratio of the Balance of Payment (as % of service exports) in Bolivia in 2005 to that in 2007?
Your answer should be very brief. 0.86. What is the ratio of the Balance of Payment (as % of service exports) in Macedonia in 2005 to that in 2007?
Your response must be concise. 0.74. What is the ratio of the Balance of Payment (as % of service exports) in Nepal in 2005 to that in 2007?
Your answer should be very brief. 0.88. What is the ratio of the Balance of Payment (as % of service exports) of Sub-Saharan Africa (developing only) in 2005 to that in 2008?
Offer a very short reply. 1.1. What is the ratio of the Balance of Payment (as % of service exports) of Macedonia in 2005 to that in 2008?
Make the answer very short. 0.72. What is the ratio of the Balance of Payment (as % of service exports) of Nepal in 2005 to that in 2008?
Your answer should be very brief. 0.75. What is the ratio of the Balance of Payment (as % of service exports) in Sub-Saharan Africa (developing only) in 2005 to that in 2009?
Your answer should be compact. 1.08. What is the ratio of the Balance of Payment (as % of service exports) of Bolivia in 2005 to that in 2009?
Keep it short and to the point. 0.94. What is the ratio of the Balance of Payment (as % of service exports) in Macedonia in 2005 to that in 2009?
Offer a terse response. 0.66. What is the ratio of the Balance of Payment (as % of service exports) of Nepal in 2005 to that in 2009?
Your answer should be compact. 0.59. What is the ratio of the Balance of Payment (as % of service exports) in Sub-Saharan Africa (developing only) in 2005 to that in 2010?
Offer a terse response. 1.13. What is the ratio of the Balance of Payment (as % of service exports) in Bolivia in 2005 to that in 2010?
Ensure brevity in your answer.  0.83. What is the ratio of the Balance of Payment (as % of service exports) of Macedonia in 2005 to that in 2010?
Your answer should be very brief. 0.65. What is the ratio of the Balance of Payment (as % of service exports) in Nepal in 2005 to that in 2010?
Provide a short and direct response. 0.67. What is the ratio of the Balance of Payment (as % of service exports) in Sub-Saharan Africa (developing only) in 2005 to that in 2011?
Provide a succinct answer. 1.17. What is the ratio of the Balance of Payment (as % of service exports) in Bolivia in 2005 to that in 2011?
Make the answer very short. 0.91. What is the ratio of the Balance of Payment (as % of service exports) in Macedonia in 2005 to that in 2011?
Offer a very short reply. 0.79. What is the ratio of the Balance of Payment (as % of service exports) of Nepal in 2005 to that in 2011?
Your answer should be compact. 0.78. What is the ratio of the Balance of Payment (as % of service exports) in Sub-Saharan Africa (developing only) in 2005 to that in 2012?
Provide a succinct answer. 1.14. What is the ratio of the Balance of Payment (as % of service exports) in Bolivia in 2005 to that in 2012?
Offer a terse response. 0.69. What is the ratio of the Balance of Payment (as % of service exports) in Macedonia in 2005 to that in 2012?
Provide a short and direct response. 0.76. What is the ratio of the Balance of Payment (as % of service exports) in Nepal in 2005 to that in 2012?
Your answer should be compact. 0.91. What is the ratio of the Balance of Payment (as % of service exports) in Sub-Saharan Africa (developing only) in 2006 to that in 2007?
Offer a terse response. 0.96. What is the ratio of the Balance of Payment (as % of service exports) of Bolivia in 2006 to that in 2007?
Ensure brevity in your answer.  0.84. What is the ratio of the Balance of Payment (as % of service exports) in Macedonia in 2006 to that in 2007?
Keep it short and to the point. 0.97. What is the ratio of the Balance of Payment (as % of service exports) in Nepal in 2006 to that in 2007?
Offer a very short reply. 0.85. What is the ratio of the Balance of Payment (as % of service exports) in Sub-Saharan Africa (developing only) in 2006 to that in 2008?
Provide a short and direct response. 1.03. What is the ratio of the Balance of Payment (as % of service exports) of Bolivia in 2006 to that in 2008?
Make the answer very short. 0.97. What is the ratio of the Balance of Payment (as % of service exports) of Macedonia in 2006 to that in 2008?
Your answer should be compact. 0.94. What is the ratio of the Balance of Payment (as % of service exports) of Nepal in 2006 to that in 2008?
Offer a very short reply. 0.72. What is the ratio of the Balance of Payment (as % of service exports) of Sub-Saharan Africa (developing only) in 2006 to that in 2009?
Your response must be concise. 1.01. What is the ratio of the Balance of Payment (as % of service exports) of Bolivia in 2006 to that in 2009?
Give a very brief answer. 0.92. What is the ratio of the Balance of Payment (as % of service exports) of Macedonia in 2006 to that in 2009?
Your response must be concise. 0.86. What is the ratio of the Balance of Payment (as % of service exports) in Nepal in 2006 to that in 2009?
Provide a succinct answer. 0.57. What is the ratio of the Balance of Payment (as % of service exports) in Sub-Saharan Africa (developing only) in 2006 to that in 2010?
Offer a very short reply. 1.05. What is the ratio of the Balance of Payment (as % of service exports) in Bolivia in 2006 to that in 2010?
Make the answer very short. 0.81. What is the ratio of the Balance of Payment (as % of service exports) in Macedonia in 2006 to that in 2010?
Offer a very short reply. 0.85. What is the ratio of the Balance of Payment (as % of service exports) in Nepal in 2006 to that in 2010?
Your answer should be compact. 0.65. What is the ratio of the Balance of Payment (as % of service exports) in Sub-Saharan Africa (developing only) in 2006 to that in 2011?
Offer a very short reply. 1.09. What is the ratio of the Balance of Payment (as % of service exports) in Bolivia in 2006 to that in 2011?
Offer a very short reply. 0.89. What is the ratio of the Balance of Payment (as % of service exports) of Macedonia in 2006 to that in 2011?
Your answer should be very brief. 1.03. What is the ratio of the Balance of Payment (as % of service exports) of Nepal in 2006 to that in 2011?
Keep it short and to the point. 0.75. What is the ratio of the Balance of Payment (as % of service exports) in Sub-Saharan Africa (developing only) in 2006 to that in 2012?
Your answer should be compact. 1.07. What is the ratio of the Balance of Payment (as % of service exports) of Bolivia in 2006 to that in 2012?
Give a very brief answer. 0.67. What is the ratio of the Balance of Payment (as % of service exports) of Macedonia in 2006 to that in 2012?
Your answer should be very brief. 1. What is the ratio of the Balance of Payment (as % of service exports) in Nepal in 2006 to that in 2012?
Offer a terse response. 0.87. What is the ratio of the Balance of Payment (as % of service exports) in Sub-Saharan Africa (developing only) in 2007 to that in 2008?
Make the answer very short. 1.08. What is the ratio of the Balance of Payment (as % of service exports) of Bolivia in 2007 to that in 2008?
Your answer should be very brief. 1.15. What is the ratio of the Balance of Payment (as % of service exports) of Macedonia in 2007 to that in 2008?
Give a very brief answer. 0.97. What is the ratio of the Balance of Payment (as % of service exports) in Nepal in 2007 to that in 2008?
Your answer should be very brief. 0.84. What is the ratio of the Balance of Payment (as % of service exports) of Sub-Saharan Africa (developing only) in 2007 to that in 2009?
Your answer should be very brief. 1.05. What is the ratio of the Balance of Payment (as % of service exports) of Bolivia in 2007 to that in 2009?
Your response must be concise. 1.09. What is the ratio of the Balance of Payment (as % of service exports) in Macedonia in 2007 to that in 2009?
Your answer should be compact. 0.89. What is the ratio of the Balance of Payment (as % of service exports) in Nepal in 2007 to that in 2009?
Keep it short and to the point. 0.67. What is the ratio of the Balance of Payment (as % of service exports) of Sub-Saharan Africa (developing only) in 2007 to that in 2010?
Offer a terse response. 1.1. What is the ratio of the Balance of Payment (as % of service exports) of Bolivia in 2007 to that in 2010?
Your answer should be compact. 0.96. What is the ratio of the Balance of Payment (as % of service exports) of Macedonia in 2007 to that in 2010?
Your answer should be very brief. 0.88. What is the ratio of the Balance of Payment (as % of service exports) in Nepal in 2007 to that in 2010?
Provide a succinct answer. 0.76. What is the ratio of the Balance of Payment (as % of service exports) of Sub-Saharan Africa (developing only) in 2007 to that in 2011?
Offer a terse response. 1.14. What is the ratio of the Balance of Payment (as % of service exports) of Bolivia in 2007 to that in 2011?
Provide a short and direct response. 1.05. What is the ratio of the Balance of Payment (as % of service exports) in Macedonia in 2007 to that in 2011?
Your answer should be very brief. 1.07. What is the ratio of the Balance of Payment (as % of service exports) of Nepal in 2007 to that in 2011?
Make the answer very short. 0.88. What is the ratio of the Balance of Payment (as % of service exports) in Sub-Saharan Africa (developing only) in 2007 to that in 2012?
Your answer should be very brief. 1.11. What is the ratio of the Balance of Payment (as % of service exports) in Bolivia in 2007 to that in 2012?
Give a very brief answer. 0.8. What is the ratio of the Balance of Payment (as % of service exports) in Macedonia in 2007 to that in 2012?
Ensure brevity in your answer.  1.03. What is the ratio of the Balance of Payment (as % of service exports) of Nepal in 2007 to that in 2012?
Make the answer very short. 1.03. What is the ratio of the Balance of Payment (as % of service exports) of Sub-Saharan Africa (developing only) in 2008 to that in 2009?
Offer a terse response. 0.98. What is the ratio of the Balance of Payment (as % of service exports) in Bolivia in 2008 to that in 2009?
Offer a very short reply. 0.94. What is the ratio of the Balance of Payment (as % of service exports) in Macedonia in 2008 to that in 2009?
Offer a very short reply. 0.92. What is the ratio of the Balance of Payment (as % of service exports) in Nepal in 2008 to that in 2009?
Make the answer very short. 0.79. What is the ratio of the Balance of Payment (as % of service exports) in Sub-Saharan Africa (developing only) in 2008 to that in 2010?
Keep it short and to the point. 1.02. What is the ratio of the Balance of Payment (as % of service exports) in Bolivia in 2008 to that in 2010?
Offer a terse response. 0.84. What is the ratio of the Balance of Payment (as % of service exports) in Macedonia in 2008 to that in 2010?
Your response must be concise. 0.91. What is the ratio of the Balance of Payment (as % of service exports) in Nepal in 2008 to that in 2010?
Provide a succinct answer. 0.9. What is the ratio of the Balance of Payment (as % of service exports) in Sub-Saharan Africa (developing only) in 2008 to that in 2011?
Your answer should be compact. 1.06. What is the ratio of the Balance of Payment (as % of service exports) of Bolivia in 2008 to that in 2011?
Ensure brevity in your answer.  0.91. What is the ratio of the Balance of Payment (as % of service exports) of Macedonia in 2008 to that in 2011?
Make the answer very short. 1.1. What is the ratio of the Balance of Payment (as % of service exports) of Nepal in 2008 to that in 2011?
Your response must be concise. 1.04. What is the ratio of the Balance of Payment (as % of service exports) in Sub-Saharan Africa (developing only) in 2008 to that in 2012?
Offer a terse response. 1.03. What is the ratio of the Balance of Payment (as % of service exports) in Bolivia in 2008 to that in 2012?
Your answer should be compact. 0.69. What is the ratio of the Balance of Payment (as % of service exports) in Macedonia in 2008 to that in 2012?
Offer a terse response. 1.06. What is the ratio of the Balance of Payment (as % of service exports) of Nepal in 2008 to that in 2012?
Give a very brief answer. 1.22. What is the ratio of the Balance of Payment (as % of service exports) of Sub-Saharan Africa (developing only) in 2009 to that in 2010?
Your response must be concise. 1.04. What is the ratio of the Balance of Payment (as % of service exports) of Bolivia in 2009 to that in 2010?
Your answer should be compact. 0.89. What is the ratio of the Balance of Payment (as % of service exports) of Macedonia in 2009 to that in 2010?
Give a very brief answer. 0.99. What is the ratio of the Balance of Payment (as % of service exports) in Nepal in 2009 to that in 2010?
Offer a terse response. 1.14. What is the ratio of the Balance of Payment (as % of service exports) of Sub-Saharan Africa (developing only) in 2009 to that in 2011?
Provide a succinct answer. 1.08. What is the ratio of the Balance of Payment (as % of service exports) of Bolivia in 2009 to that in 2011?
Your answer should be very brief. 0.97. What is the ratio of the Balance of Payment (as % of service exports) in Macedonia in 2009 to that in 2011?
Make the answer very short. 1.19. What is the ratio of the Balance of Payment (as % of service exports) of Nepal in 2009 to that in 2011?
Provide a short and direct response. 1.32. What is the ratio of the Balance of Payment (as % of service exports) in Sub-Saharan Africa (developing only) in 2009 to that in 2012?
Make the answer very short. 1.06. What is the ratio of the Balance of Payment (as % of service exports) in Bolivia in 2009 to that in 2012?
Your answer should be compact. 0.73. What is the ratio of the Balance of Payment (as % of service exports) of Macedonia in 2009 to that in 2012?
Offer a terse response. 1.15. What is the ratio of the Balance of Payment (as % of service exports) of Nepal in 2009 to that in 2012?
Your answer should be very brief. 1.54. What is the ratio of the Balance of Payment (as % of service exports) in Sub-Saharan Africa (developing only) in 2010 to that in 2011?
Ensure brevity in your answer.  1.04. What is the ratio of the Balance of Payment (as % of service exports) of Bolivia in 2010 to that in 2011?
Give a very brief answer. 1.09. What is the ratio of the Balance of Payment (as % of service exports) in Macedonia in 2010 to that in 2011?
Offer a terse response. 1.21. What is the ratio of the Balance of Payment (as % of service exports) of Nepal in 2010 to that in 2011?
Your response must be concise. 1.16. What is the ratio of the Balance of Payment (as % of service exports) in Sub-Saharan Africa (developing only) in 2010 to that in 2012?
Provide a short and direct response. 1.01. What is the ratio of the Balance of Payment (as % of service exports) of Bolivia in 2010 to that in 2012?
Your response must be concise. 0.83. What is the ratio of the Balance of Payment (as % of service exports) of Macedonia in 2010 to that in 2012?
Make the answer very short. 1.16. What is the ratio of the Balance of Payment (as % of service exports) of Nepal in 2010 to that in 2012?
Your response must be concise. 1.35. What is the ratio of the Balance of Payment (as % of service exports) of Sub-Saharan Africa (developing only) in 2011 to that in 2012?
Give a very brief answer. 0.98. What is the ratio of the Balance of Payment (as % of service exports) of Bolivia in 2011 to that in 2012?
Provide a succinct answer. 0.76. What is the ratio of the Balance of Payment (as % of service exports) of Macedonia in 2011 to that in 2012?
Offer a terse response. 0.96. What is the ratio of the Balance of Payment (as % of service exports) of Nepal in 2011 to that in 2012?
Your answer should be very brief. 1.17. What is the difference between the highest and the second highest Balance of Payment (as % of service exports) in Sub-Saharan Africa (developing only)?
Provide a short and direct response. 1.2. What is the difference between the highest and the second highest Balance of Payment (as % of service exports) of Bolivia?
Keep it short and to the point. 9.06. What is the difference between the highest and the second highest Balance of Payment (as % of service exports) in Macedonia?
Give a very brief answer. 0.21. What is the difference between the highest and the second highest Balance of Payment (as % of service exports) of Nepal?
Your answer should be very brief. 7.34. What is the difference between the highest and the lowest Balance of Payment (as % of service exports) of Sub-Saharan Africa (developing only)?
Make the answer very short. 7.14. What is the difference between the highest and the lowest Balance of Payment (as % of service exports) in Bolivia?
Your response must be concise. 17.31. What is the difference between the highest and the lowest Balance of Payment (as % of service exports) in Macedonia?
Offer a very short reply. 6.91. What is the difference between the highest and the lowest Balance of Payment (as % of service exports) of Nepal?
Your response must be concise. 25.43. 